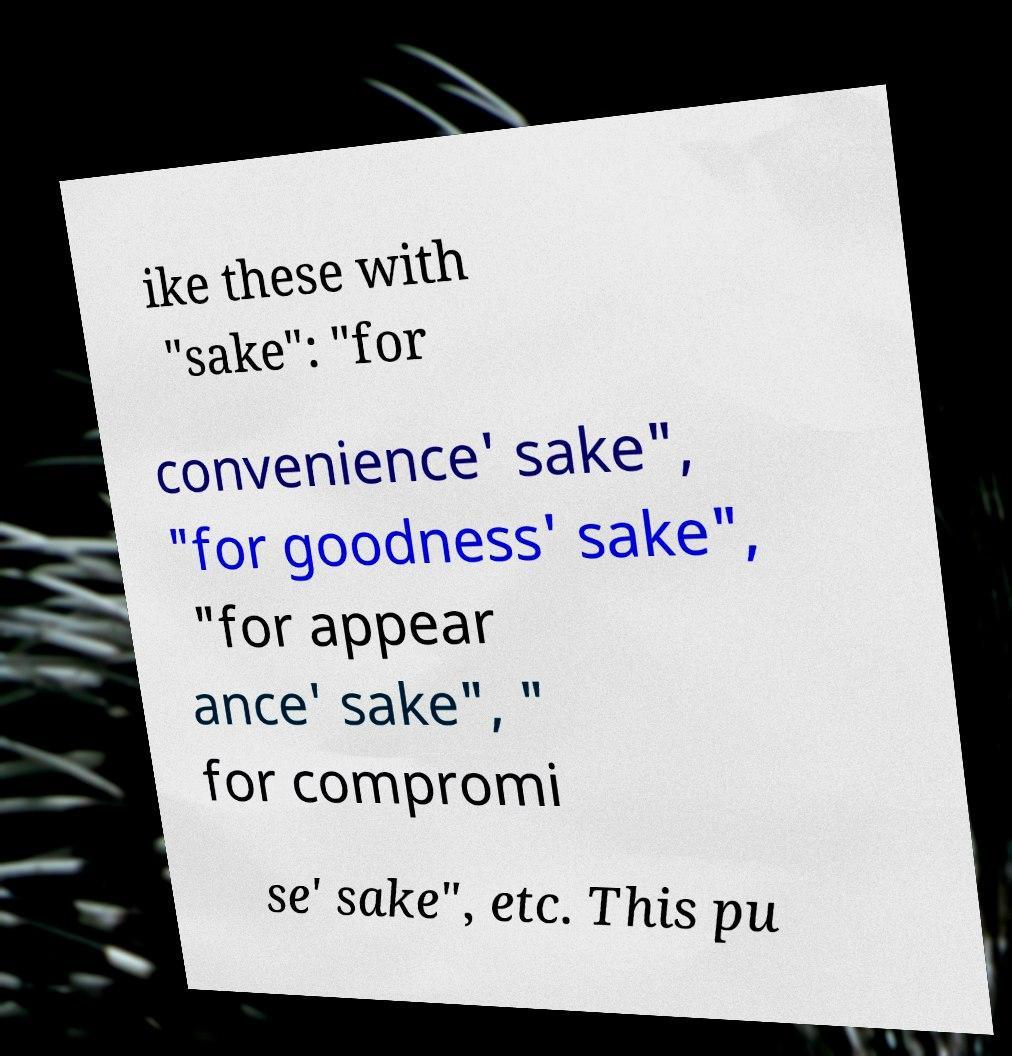Please read and relay the text visible in this image. What does it say? ike these with "sake": "for convenience' sake", "for goodness' sake", "for appear ance' sake", " for compromi se' sake", etc. This pu 